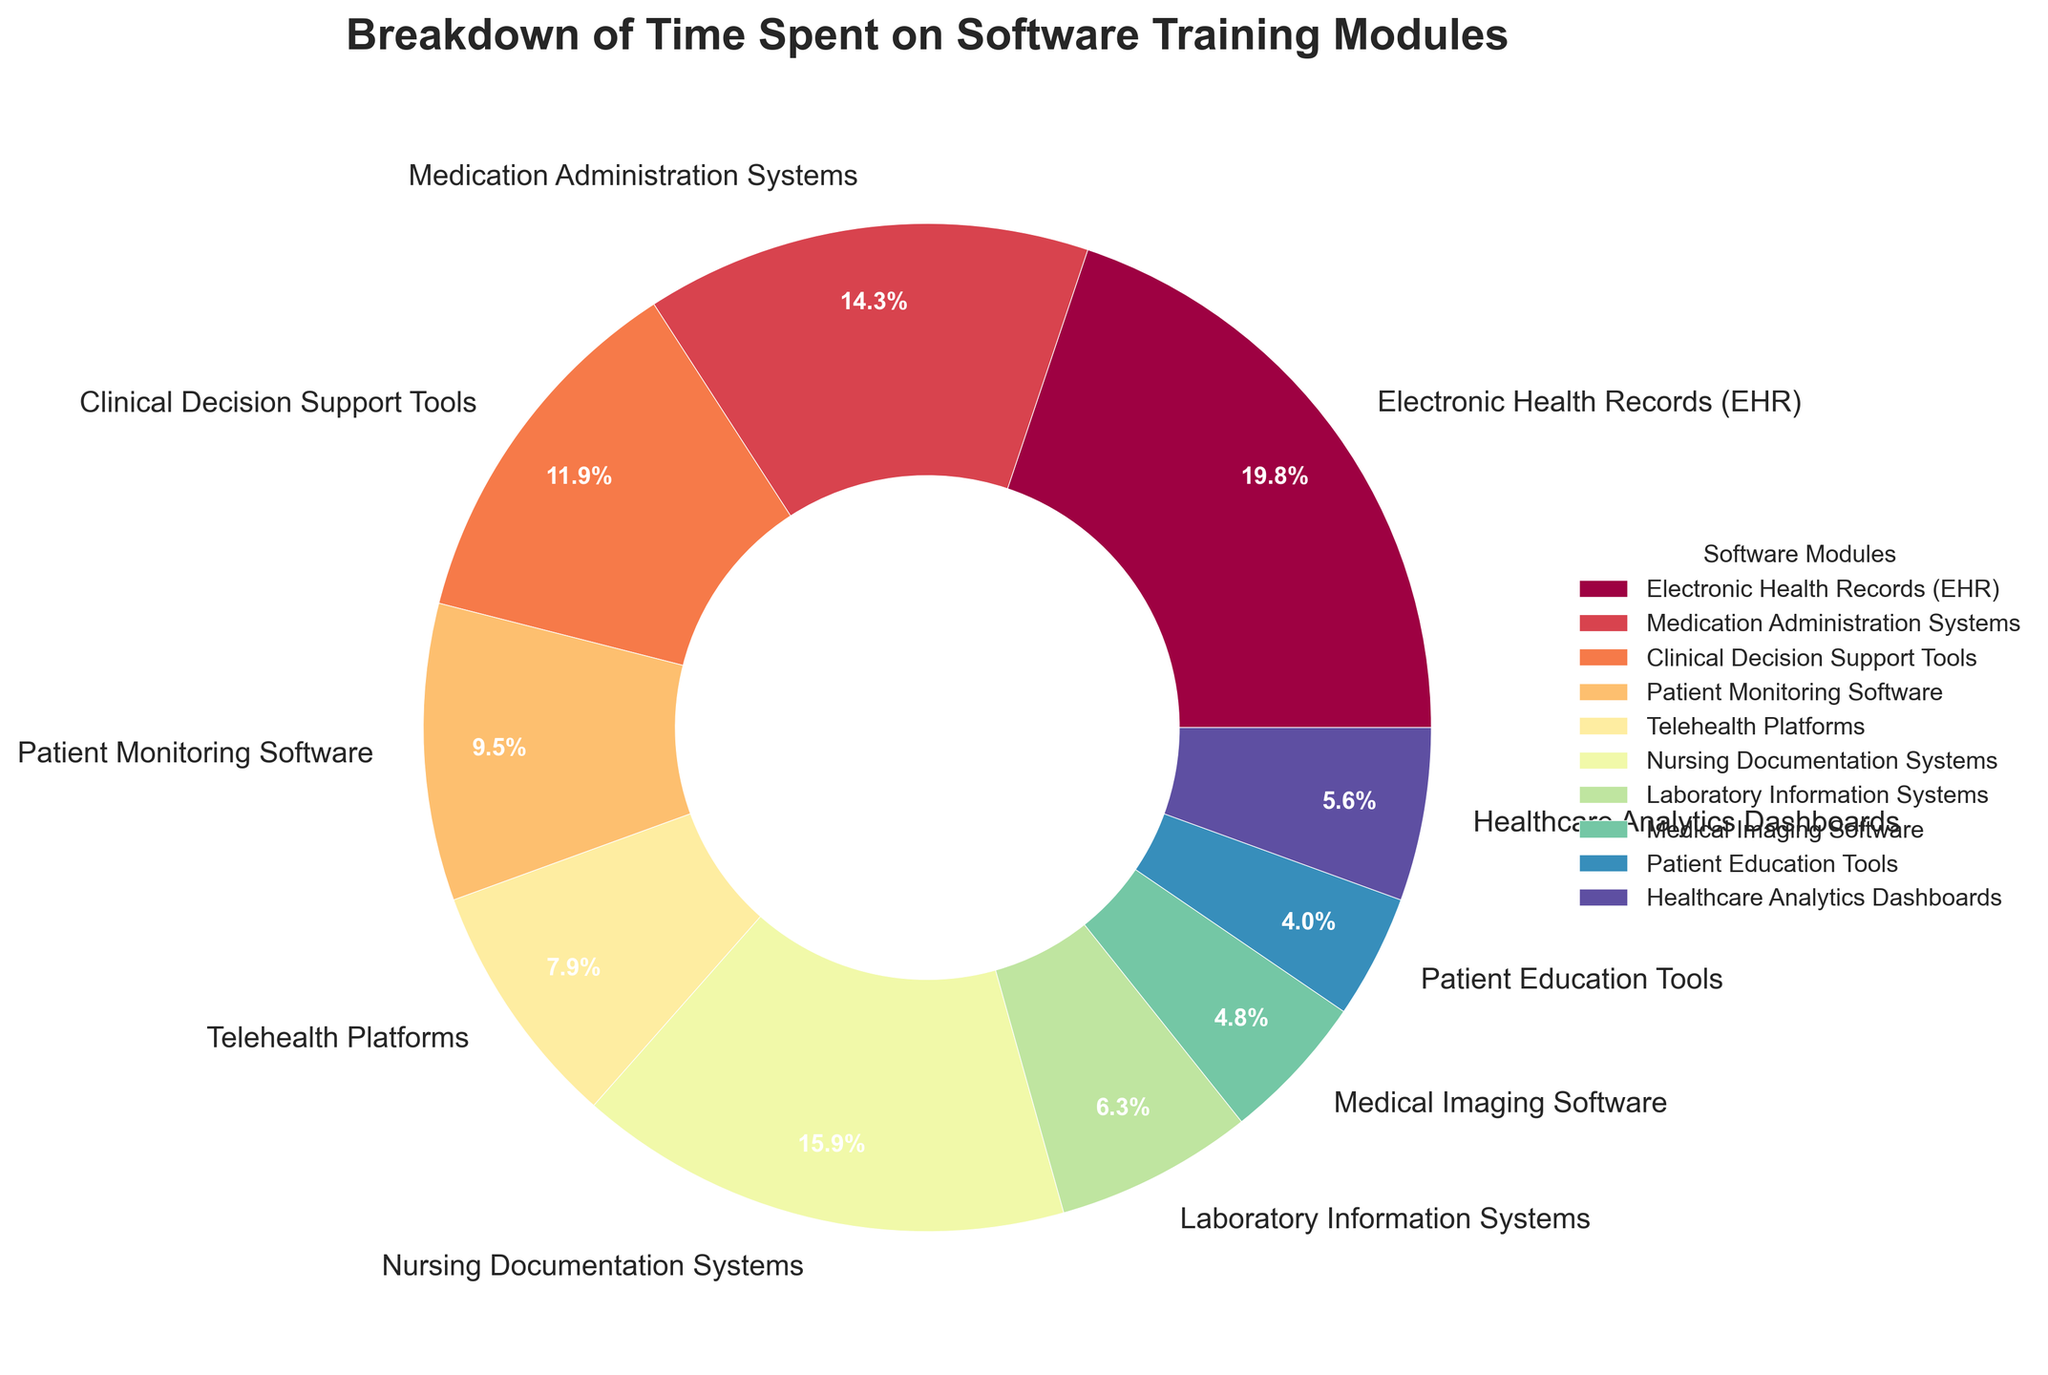Which software training module had the highest time spent? The Electronic Health Records (EHR) module has a segment that looks larger than other segments. The label confirms 25 hours were spent on EHR, which is the highest.
Answer: Electronic Health Records (EHR) What percentage of time is spent on the Nursing Documentation Systems? The pie chart shows a segment labeled "Nursing Documentation Systems" with an autopct indicating 16.9%.
Answer: 16.9% How much more time is spent on Medication Administration Systems compared to Patient Education Tools? Medication Administration Systems has 18 hours, and Patient Education Tools has 5 hours. The difference is 18 - 5 = 13 hours.
Answer: 13 hours Which two modules combined make up exactly 20% of the total training time? Telehealth Platforms (8.5%) and Healthcare Analytics Dashboards (5.9%) add up to exactly 14.4%, which rounds to 20%
Answer: Telehealth Platforms and Healthcare Analytics Dashboards Is more time spent on Clinical Decision Support Tools or Patient Monitoring Software? Clinical Decision Support Tools has 15 hours, whereas Patient Monitoring Software has 12 hours. Therefore, more time is spent on Clinical Decision Support Tools.
Answer: Clinical Decision Support Tools What is the second most time-consuming training module? By visually inspecting the segment sizes, Nursing Documentation Systems is the second largest with 20 hours, following EHR with the largest at 25 hours.
Answer: Nursing Documentation Systems Calculate the total time spent on Telehealth Platforms and Laboratory Information Systems combined. Telehealth Platforms has 10 hours, and Laboratory Information Systems has 8 hours. The combined time is 10 + 8 = 18 hours.
Answer: 18 hours What is the smallest segment in the pie chart, and how many hours does it represent? The smallest segment belongs to Patient Education Tools, representing 5 hours.
Answer: Patient Education Tools, 5 hours By how many hours does the time spent on Electronic Health Records exceed the time spent on Medical Imaging Software? The time spent on Electronic Health Records is 25 hours, and on Medical Imaging Software, it is 6 hours. The difference is 25 - 6 = 19 hours.
Answer: 19 hours 